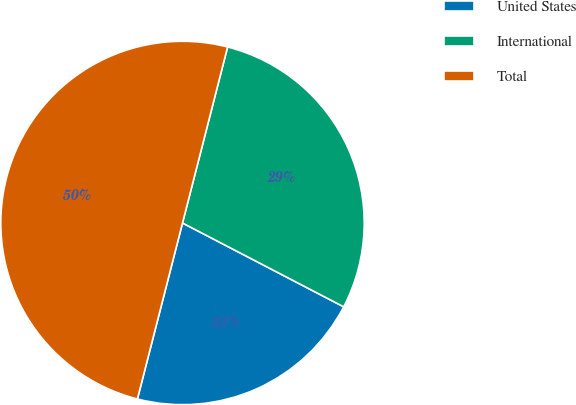Convert chart to OTSL. <chart><loc_0><loc_0><loc_500><loc_500><pie_chart><fcel>United States<fcel>International<fcel>Total<nl><fcel>21.36%<fcel>28.64%<fcel>50.0%<nl></chart> 